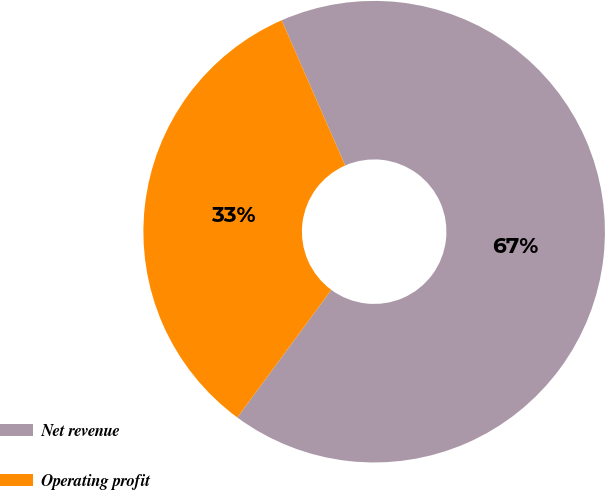Convert chart. <chart><loc_0><loc_0><loc_500><loc_500><pie_chart><fcel>Net revenue<fcel>Operating profit<nl><fcel>66.67%<fcel>33.33%<nl></chart> 